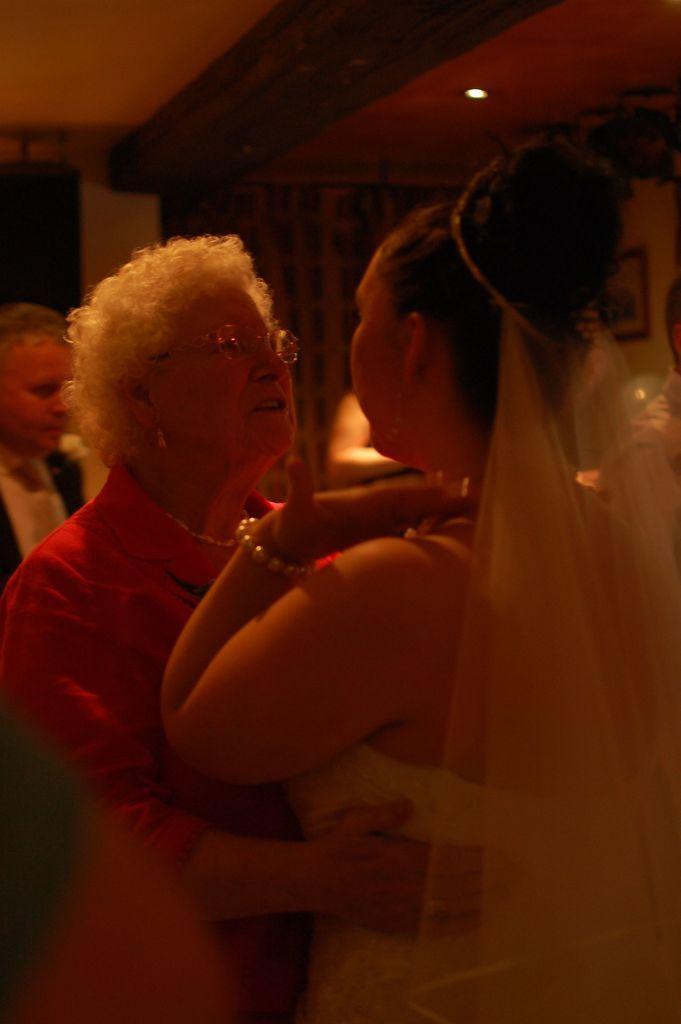Could you give a brief overview of what you see in this image? In this picture we can see a person holding a woman. There is a frame on the wall. We can see a few people in the background. 